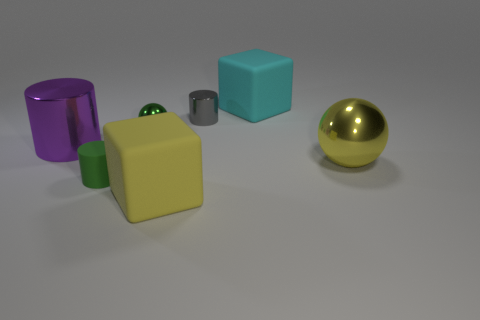Subtract all tiny gray shiny cylinders. How many cylinders are left? 2 Add 3 green metallic objects. How many objects exist? 10 Subtract all purple cylinders. How many cylinders are left? 2 Subtract 1 balls. How many balls are left? 1 Subtract all green spheres. How many green cylinders are left? 1 Subtract all red shiny cylinders. Subtract all blocks. How many objects are left? 5 Add 1 big cyan matte things. How many big cyan matte things are left? 2 Add 2 small blue metal cylinders. How many small blue metal cylinders exist? 2 Subtract 1 gray cylinders. How many objects are left? 6 Subtract all balls. How many objects are left? 5 